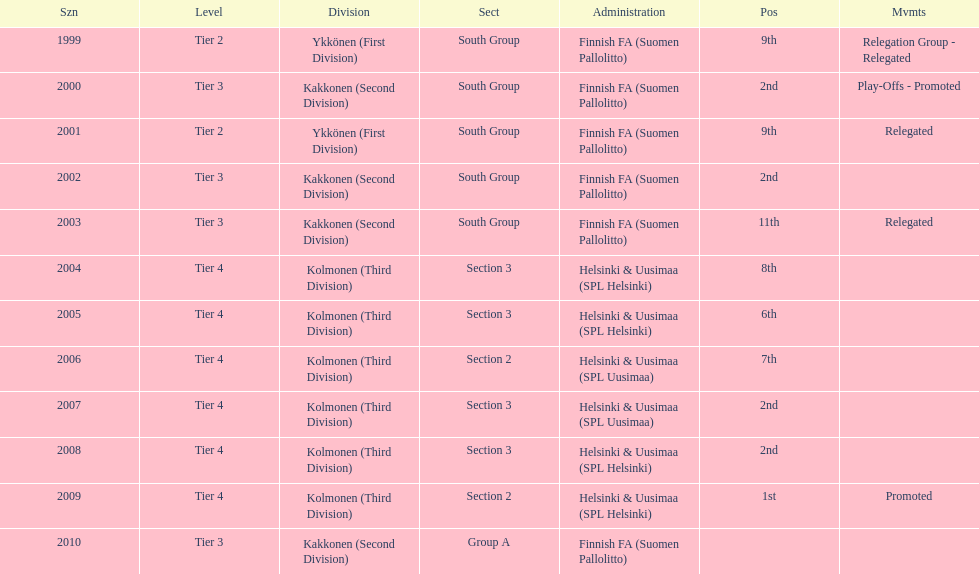What is the first tier listed? Tier 2. 